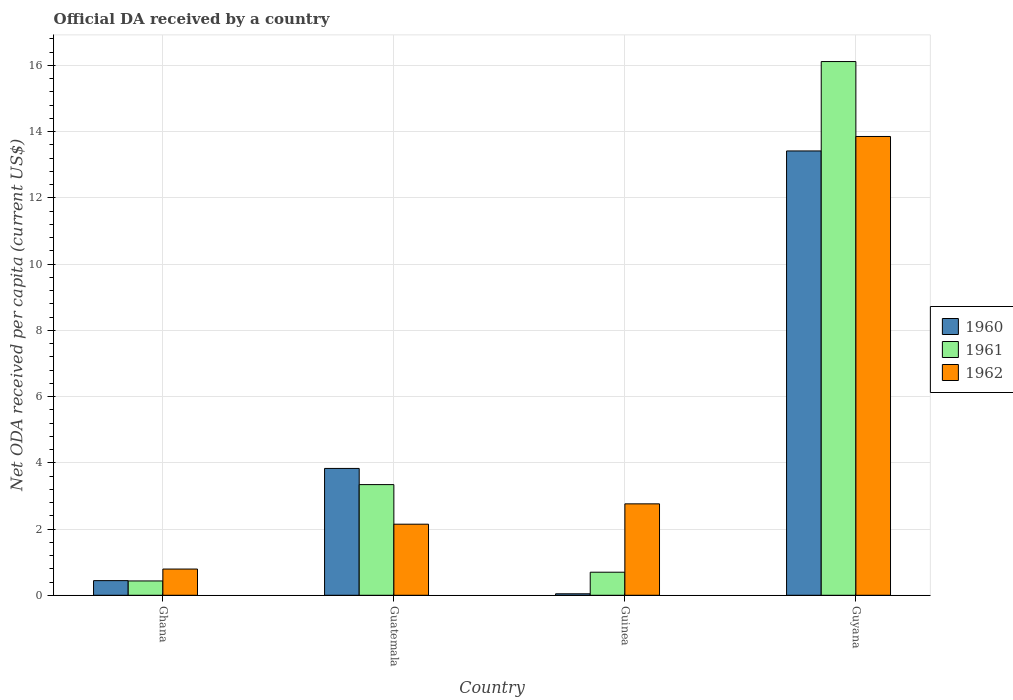How many different coloured bars are there?
Give a very brief answer. 3. Are the number of bars per tick equal to the number of legend labels?
Offer a very short reply. Yes. What is the label of the 3rd group of bars from the left?
Offer a terse response. Guinea. What is the ODA received in in 1960 in Ghana?
Offer a very short reply. 0.44. Across all countries, what is the maximum ODA received in in 1962?
Offer a terse response. 13.85. Across all countries, what is the minimum ODA received in in 1962?
Your answer should be compact. 0.79. In which country was the ODA received in in 1961 maximum?
Offer a terse response. Guyana. In which country was the ODA received in in 1961 minimum?
Offer a very short reply. Ghana. What is the total ODA received in in 1961 in the graph?
Provide a succinct answer. 20.59. What is the difference between the ODA received in in 1961 in Ghana and that in Guyana?
Offer a very short reply. -15.68. What is the difference between the ODA received in in 1960 in Guinea and the ODA received in in 1961 in Guatemala?
Provide a short and direct response. -3.3. What is the average ODA received in in 1960 per country?
Make the answer very short. 4.43. What is the difference between the ODA received in of/in 1960 and ODA received in of/in 1961 in Ghana?
Your response must be concise. 0.01. What is the ratio of the ODA received in in 1960 in Ghana to that in Guyana?
Offer a terse response. 0.03. Is the ODA received in in 1960 in Guatemala less than that in Guyana?
Provide a succinct answer. Yes. Is the difference between the ODA received in in 1960 in Ghana and Guinea greater than the difference between the ODA received in in 1961 in Ghana and Guinea?
Provide a short and direct response. Yes. What is the difference between the highest and the second highest ODA received in in 1961?
Keep it short and to the point. 15.42. What is the difference between the highest and the lowest ODA received in in 1961?
Your answer should be compact. 15.68. Are all the bars in the graph horizontal?
Ensure brevity in your answer.  No. Are the values on the major ticks of Y-axis written in scientific E-notation?
Your answer should be compact. No. What is the title of the graph?
Offer a very short reply. Official DA received by a country. Does "1991" appear as one of the legend labels in the graph?
Make the answer very short. No. What is the label or title of the X-axis?
Give a very brief answer. Country. What is the label or title of the Y-axis?
Ensure brevity in your answer.  Net ODA received per capita (current US$). What is the Net ODA received per capita (current US$) in 1960 in Ghana?
Offer a terse response. 0.44. What is the Net ODA received per capita (current US$) in 1961 in Ghana?
Your answer should be compact. 0.43. What is the Net ODA received per capita (current US$) in 1962 in Ghana?
Give a very brief answer. 0.79. What is the Net ODA received per capita (current US$) of 1960 in Guatemala?
Your answer should be compact. 3.83. What is the Net ODA received per capita (current US$) in 1961 in Guatemala?
Give a very brief answer. 3.34. What is the Net ODA received per capita (current US$) in 1962 in Guatemala?
Give a very brief answer. 2.15. What is the Net ODA received per capita (current US$) in 1960 in Guinea?
Your response must be concise. 0.04. What is the Net ODA received per capita (current US$) of 1961 in Guinea?
Keep it short and to the point. 0.7. What is the Net ODA received per capita (current US$) of 1962 in Guinea?
Your answer should be compact. 2.76. What is the Net ODA received per capita (current US$) in 1960 in Guyana?
Make the answer very short. 13.42. What is the Net ODA received per capita (current US$) of 1961 in Guyana?
Your response must be concise. 16.12. What is the Net ODA received per capita (current US$) in 1962 in Guyana?
Give a very brief answer. 13.85. Across all countries, what is the maximum Net ODA received per capita (current US$) in 1960?
Provide a succinct answer. 13.42. Across all countries, what is the maximum Net ODA received per capita (current US$) in 1961?
Ensure brevity in your answer.  16.12. Across all countries, what is the maximum Net ODA received per capita (current US$) in 1962?
Your answer should be very brief. 13.85. Across all countries, what is the minimum Net ODA received per capita (current US$) of 1960?
Give a very brief answer. 0.04. Across all countries, what is the minimum Net ODA received per capita (current US$) in 1961?
Provide a succinct answer. 0.43. Across all countries, what is the minimum Net ODA received per capita (current US$) of 1962?
Offer a very short reply. 0.79. What is the total Net ODA received per capita (current US$) of 1960 in the graph?
Give a very brief answer. 17.73. What is the total Net ODA received per capita (current US$) in 1961 in the graph?
Provide a succinct answer. 20.59. What is the total Net ODA received per capita (current US$) of 1962 in the graph?
Your answer should be compact. 19.55. What is the difference between the Net ODA received per capita (current US$) in 1960 in Ghana and that in Guatemala?
Your answer should be very brief. -3.39. What is the difference between the Net ODA received per capita (current US$) of 1961 in Ghana and that in Guatemala?
Your answer should be very brief. -2.91. What is the difference between the Net ODA received per capita (current US$) of 1962 in Ghana and that in Guatemala?
Your answer should be very brief. -1.35. What is the difference between the Net ODA received per capita (current US$) in 1960 in Ghana and that in Guinea?
Your response must be concise. 0.4. What is the difference between the Net ODA received per capita (current US$) in 1961 in Ghana and that in Guinea?
Your answer should be very brief. -0.26. What is the difference between the Net ODA received per capita (current US$) of 1962 in Ghana and that in Guinea?
Keep it short and to the point. -1.97. What is the difference between the Net ODA received per capita (current US$) in 1960 in Ghana and that in Guyana?
Provide a succinct answer. -12.97. What is the difference between the Net ODA received per capita (current US$) in 1961 in Ghana and that in Guyana?
Your answer should be compact. -15.68. What is the difference between the Net ODA received per capita (current US$) of 1962 in Ghana and that in Guyana?
Give a very brief answer. -13.06. What is the difference between the Net ODA received per capita (current US$) of 1960 in Guatemala and that in Guinea?
Provide a short and direct response. 3.79. What is the difference between the Net ODA received per capita (current US$) in 1961 in Guatemala and that in Guinea?
Your answer should be compact. 2.65. What is the difference between the Net ODA received per capita (current US$) of 1962 in Guatemala and that in Guinea?
Offer a very short reply. -0.61. What is the difference between the Net ODA received per capita (current US$) in 1960 in Guatemala and that in Guyana?
Ensure brevity in your answer.  -9.59. What is the difference between the Net ODA received per capita (current US$) of 1961 in Guatemala and that in Guyana?
Ensure brevity in your answer.  -12.77. What is the difference between the Net ODA received per capita (current US$) of 1962 in Guatemala and that in Guyana?
Your answer should be very brief. -11.71. What is the difference between the Net ODA received per capita (current US$) of 1960 in Guinea and that in Guyana?
Your answer should be very brief. -13.37. What is the difference between the Net ODA received per capita (current US$) of 1961 in Guinea and that in Guyana?
Your response must be concise. -15.42. What is the difference between the Net ODA received per capita (current US$) of 1962 in Guinea and that in Guyana?
Offer a terse response. -11.09. What is the difference between the Net ODA received per capita (current US$) of 1960 in Ghana and the Net ODA received per capita (current US$) of 1962 in Guatemala?
Keep it short and to the point. -1.7. What is the difference between the Net ODA received per capita (current US$) in 1961 in Ghana and the Net ODA received per capita (current US$) in 1962 in Guatemala?
Provide a short and direct response. -1.71. What is the difference between the Net ODA received per capita (current US$) in 1960 in Ghana and the Net ODA received per capita (current US$) in 1961 in Guinea?
Your answer should be very brief. -0.25. What is the difference between the Net ODA received per capita (current US$) of 1960 in Ghana and the Net ODA received per capita (current US$) of 1962 in Guinea?
Provide a short and direct response. -2.32. What is the difference between the Net ODA received per capita (current US$) in 1961 in Ghana and the Net ODA received per capita (current US$) in 1962 in Guinea?
Give a very brief answer. -2.33. What is the difference between the Net ODA received per capita (current US$) in 1960 in Ghana and the Net ODA received per capita (current US$) in 1961 in Guyana?
Make the answer very short. -15.67. What is the difference between the Net ODA received per capita (current US$) of 1960 in Ghana and the Net ODA received per capita (current US$) of 1962 in Guyana?
Make the answer very short. -13.41. What is the difference between the Net ODA received per capita (current US$) in 1961 in Ghana and the Net ODA received per capita (current US$) in 1962 in Guyana?
Offer a terse response. -13.42. What is the difference between the Net ODA received per capita (current US$) in 1960 in Guatemala and the Net ODA received per capita (current US$) in 1961 in Guinea?
Your answer should be compact. 3.13. What is the difference between the Net ODA received per capita (current US$) in 1960 in Guatemala and the Net ODA received per capita (current US$) in 1962 in Guinea?
Your answer should be compact. 1.07. What is the difference between the Net ODA received per capita (current US$) in 1961 in Guatemala and the Net ODA received per capita (current US$) in 1962 in Guinea?
Keep it short and to the point. 0.58. What is the difference between the Net ODA received per capita (current US$) of 1960 in Guatemala and the Net ODA received per capita (current US$) of 1961 in Guyana?
Your answer should be very brief. -12.29. What is the difference between the Net ODA received per capita (current US$) in 1960 in Guatemala and the Net ODA received per capita (current US$) in 1962 in Guyana?
Your answer should be compact. -10.02. What is the difference between the Net ODA received per capita (current US$) of 1961 in Guatemala and the Net ODA received per capita (current US$) of 1962 in Guyana?
Offer a very short reply. -10.51. What is the difference between the Net ODA received per capita (current US$) of 1960 in Guinea and the Net ODA received per capita (current US$) of 1961 in Guyana?
Offer a very short reply. -16.07. What is the difference between the Net ODA received per capita (current US$) of 1960 in Guinea and the Net ODA received per capita (current US$) of 1962 in Guyana?
Provide a short and direct response. -13.81. What is the difference between the Net ODA received per capita (current US$) in 1961 in Guinea and the Net ODA received per capita (current US$) in 1962 in Guyana?
Your answer should be very brief. -13.16. What is the average Net ODA received per capita (current US$) in 1960 per country?
Provide a short and direct response. 4.43. What is the average Net ODA received per capita (current US$) in 1961 per country?
Offer a terse response. 5.15. What is the average Net ODA received per capita (current US$) of 1962 per country?
Provide a short and direct response. 4.89. What is the difference between the Net ODA received per capita (current US$) of 1960 and Net ODA received per capita (current US$) of 1961 in Ghana?
Make the answer very short. 0.01. What is the difference between the Net ODA received per capita (current US$) of 1960 and Net ODA received per capita (current US$) of 1962 in Ghana?
Make the answer very short. -0.35. What is the difference between the Net ODA received per capita (current US$) in 1961 and Net ODA received per capita (current US$) in 1962 in Ghana?
Your answer should be compact. -0.36. What is the difference between the Net ODA received per capita (current US$) in 1960 and Net ODA received per capita (current US$) in 1961 in Guatemala?
Your answer should be compact. 0.49. What is the difference between the Net ODA received per capita (current US$) in 1960 and Net ODA received per capita (current US$) in 1962 in Guatemala?
Your answer should be compact. 1.68. What is the difference between the Net ODA received per capita (current US$) in 1961 and Net ODA received per capita (current US$) in 1962 in Guatemala?
Offer a terse response. 1.2. What is the difference between the Net ODA received per capita (current US$) of 1960 and Net ODA received per capita (current US$) of 1961 in Guinea?
Provide a succinct answer. -0.65. What is the difference between the Net ODA received per capita (current US$) of 1960 and Net ODA received per capita (current US$) of 1962 in Guinea?
Your response must be concise. -2.72. What is the difference between the Net ODA received per capita (current US$) of 1961 and Net ODA received per capita (current US$) of 1962 in Guinea?
Your response must be concise. -2.06. What is the difference between the Net ODA received per capita (current US$) of 1960 and Net ODA received per capita (current US$) of 1961 in Guyana?
Your response must be concise. -2.7. What is the difference between the Net ODA received per capita (current US$) of 1960 and Net ODA received per capita (current US$) of 1962 in Guyana?
Make the answer very short. -0.44. What is the difference between the Net ODA received per capita (current US$) in 1961 and Net ODA received per capita (current US$) in 1962 in Guyana?
Your response must be concise. 2.26. What is the ratio of the Net ODA received per capita (current US$) in 1960 in Ghana to that in Guatemala?
Provide a short and direct response. 0.12. What is the ratio of the Net ODA received per capita (current US$) of 1961 in Ghana to that in Guatemala?
Make the answer very short. 0.13. What is the ratio of the Net ODA received per capita (current US$) of 1962 in Ghana to that in Guatemala?
Your answer should be compact. 0.37. What is the ratio of the Net ODA received per capita (current US$) in 1960 in Ghana to that in Guinea?
Provide a short and direct response. 9.88. What is the ratio of the Net ODA received per capita (current US$) in 1961 in Ghana to that in Guinea?
Offer a terse response. 0.62. What is the ratio of the Net ODA received per capita (current US$) of 1962 in Ghana to that in Guinea?
Your response must be concise. 0.29. What is the ratio of the Net ODA received per capita (current US$) of 1960 in Ghana to that in Guyana?
Your response must be concise. 0.03. What is the ratio of the Net ODA received per capita (current US$) in 1961 in Ghana to that in Guyana?
Your answer should be very brief. 0.03. What is the ratio of the Net ODA received per capita (current US$) in 1962 in Ghana to that in Guyana?
Keep it short and to the point. 0.06. What is the ratio of the Net ODA received per capita (current US$) of 1960 in Guatemala to that in Guinea?
Your response must be concise. 85.64. What is the ratio of the Net ODA received per capita (current US$) of 1961 in Guatemala to that in Guinea?
Provide a short and direct response. 4.8. What is the ratio of the Net ODA received per capita (current US$) in 1962 in Guatemala to that in Guinea?
Your response must be concise. 0.78. What is the ratio of the Net ODA received per capita (current US$) of 1960 in Guatemala to that in Guyana?
Provide a short and direct response. 0.29. What is the ratio of the Net ODA received per capita (current US$) of 1961 in Guatemala to that in Guyana?
Ensure brevity in your answer.  0.21. What is the ratio of the Net ODA received per capita (current US$) in 1962 in Guatemala to that in Guyana?
Provide a short and direct response. 0.15. What is the ratio of the Net ODA received per capita (current US$) of 1960 in Guinea to that in Guyana?
Your response must be concise. 0. What is the ratio of the Net ODA received per capita (current US$) in 1961 in Guinea to that in Guyana?
Give a very brief answer. 0.04. What is the ratio of the Net ODA received per capita (current US$) of 1962 in Guinea to that in Guyana?
Offer a terse response. 0.2. What is the difference between the highest and the second highest Net ODA received per capita (current US$) in 1960?
Give a very brief answer. 9.59. What is the difference between the highest and the second highest Net ODA received per capita (current US$) in 1961?
Provide a short and direct response. 12.77. What is the difference between the highest and the second highest Net ODA received per capita (current US$) of 1962?
Your response must be concise. 11.09. What is the difference between the highest and the lowest Net ODA received per capita (current US$) in 1960?
Your answer should be very brief. 13.37. What is the difference between the highest and the lowest Net ODA received per capita (current US$) in 1961?
Give a very brief answer. 15.68. What is the difference between the highest and the lowest Net ODA received per capita (current US$) in 1962?
Provide a short and direct response. 13.06. 